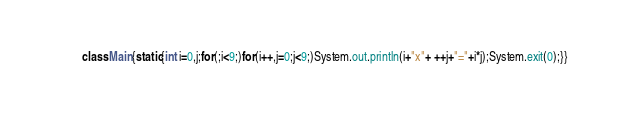Convert code to text. <code><loc_0><loc_0><loc_500><loc_500><_Java_>class Main{static{int i=0,j;for(;i<9;)for(i++,j=0;j<9;)System.out.println(i+"x"+ ++j+"="+i*j);System.exit(0);}}</code> 